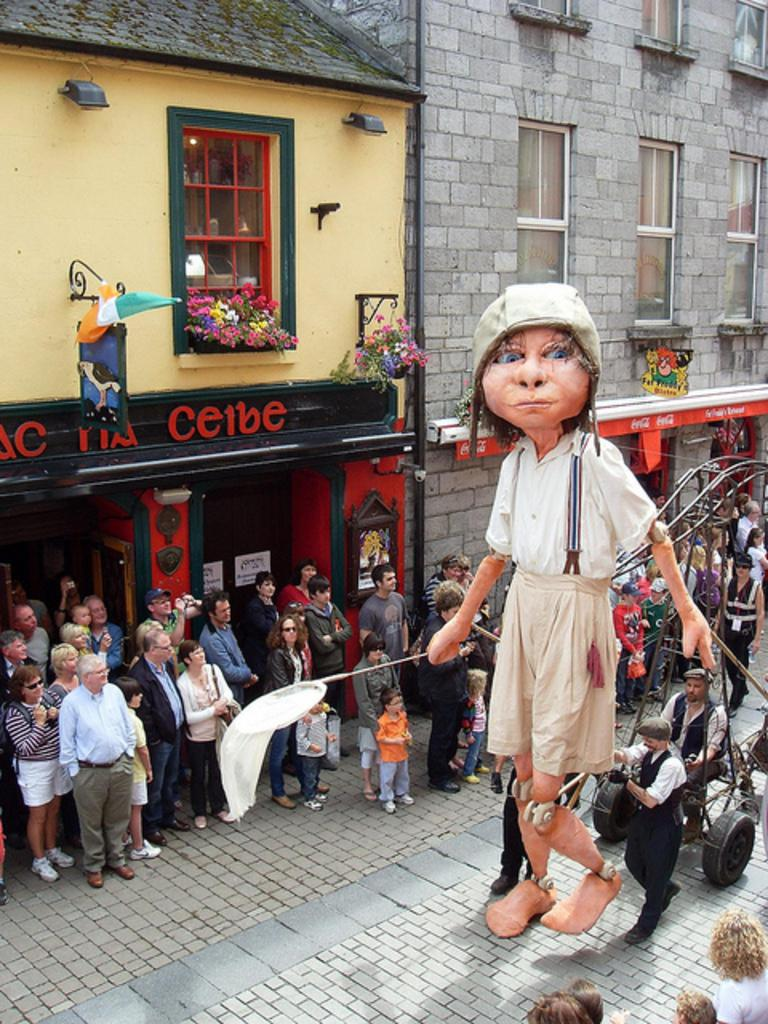What character can be seen on the right side of the image? There is a clown on the right side of the image. What else is present in the image besides the clown? There are people standing in the image. What object can be used for transporting items in the image? There is a trolley in the image. What can be seen in the distance in the image? There are buildings in the background of the image. Where is the nest located in the image? There is no nest present in the image. What type of headwear is the clown wearing in the image? The provided facts do not mention any headwear worn by the clown in the image. 